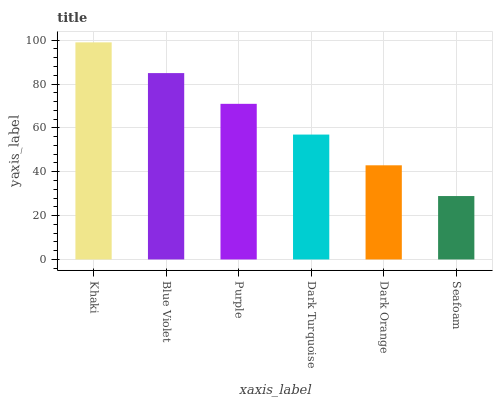Is Blue Violet the minimum?
Answer yes or no. No. Is Blue Violet the maximum?
Answer yes or no. No. Is Khaki greater than Blue Violet?
Answer yes or no. Yes. Is Blue Violet less than Khaki?
Answer yes or no. Yes. Is Blue Violet greater than Khaki?
Answer yes or no. No. Is Khaki less than Blue Violet?
Answer yes or no. No. Is Purple the high median?
Answer yes or no. Yes. Is Dark Turquoise the low median?
Answer yes or no. Yes. Is Seafoam the high median?
Answer yes or no. No. Is Khaki the low median?
Answer yes or no. No. 